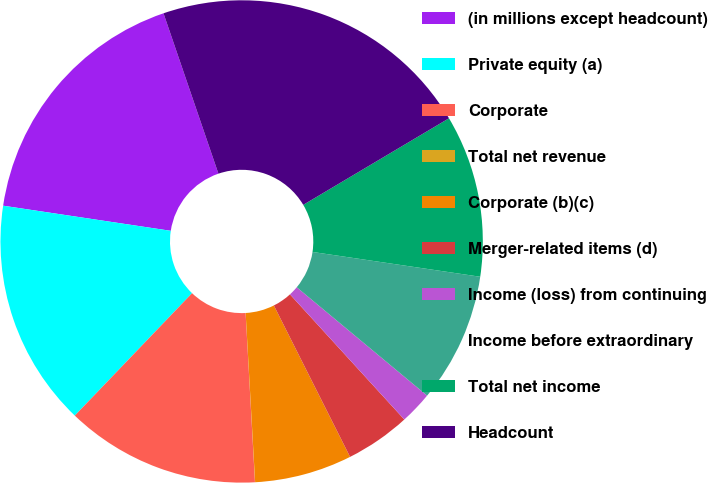Convert chart to OTSL. <chart><loc_0><loc_0><loc_500><loc_500><pie_chart><fcel>(in millions except headcount)<fcel>Private equity (a)<fcel>Corporate<fcel>Total net revenue<fcel>Corporate (b)(c)<fcel>Merger-related items (d)<fcel>Income (loss) from continuing<fcel>Income before extraordinary<fcel>Total net income<fcel>Headcount<nl><fcel>17.38%<fcel>15.21%<fcel>13.04%<fcel>0.01%<fcel>6.53%<fcel>4.36%<fcel>2.18%<fcel>8.7%<fcel>10.87%<fcel>21.72%<nl></chart> 